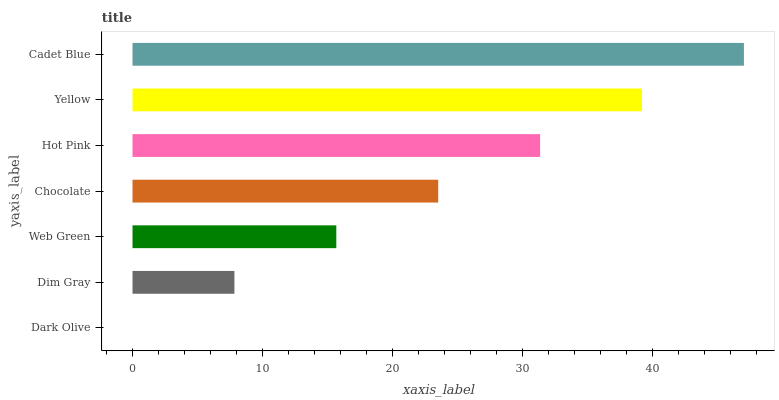Is Dark Olive the minimum?
Answer yes or no. Yes. Is Cadet Blue the maximum?
Answer yes or no. Yes. Is Dim Gray the minimum?
Answer yes or no. No. Is Dim Gray the maximum?
Answer yes or no. No. Is Dim Gray greater than Dark Olive?
Answer yes or no. Yes. Is Dark Olive less than Dim Gray?
Answer yes or no. Yes. Is Dark Olive greater than Dim Gray?
Answer yes or no. No. Is Dim Gray less than Dark Olive?
Answer yes or no. No. Is Chocolate the high median?
Answer yes or no. Yes. Is Chocolate the low median?
Answer yes or no. Yes. Is Hot Pink the high median?
Answer yes or no. No. Is Cadet Blue the low median?
Answer yes or no. No. 